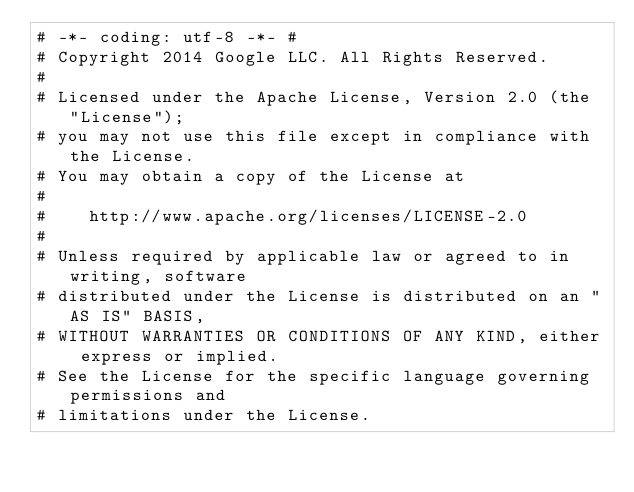Convert code to text. <code><loc_0><loc_0><loc_500><loc_500><_Python_># -*- coding: utf-8 -*- #
# Copyright 2014 Google LLC. All Rights Reserved.
#
# Licensed under the Apache License, Version 2.0 (the "License");
# you may not use this file except in compliance with the License.
# You may obtain a copy of the License at
#
#    http://www.apache.org/licenses/LICENSE-2.0
#
# Unless required by applicable law or agreed to in writing, software
# distributed under the License is distributed on an "AS IS" BASIS,
# WITHOUT WARRANTIES OR CONDITIONS OF ANY KIND, either express or implied.
# See the License for the specific language governing permissions and
# limitations under the License.
</code> 